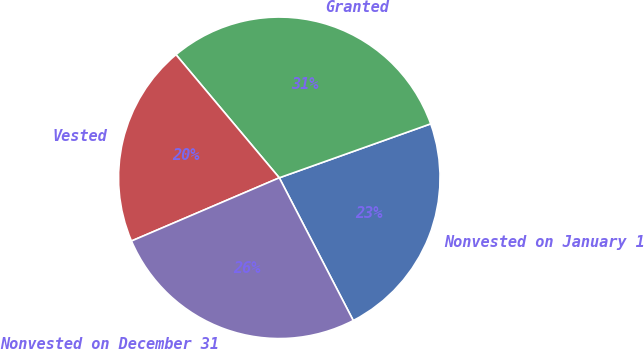Convert chart to OTSL. <chart><loc_0><loc_0><loc_500><loc_500><pie_chart><fcel>Nonvested on January 1<fcel>Granted<fcel>Vested<fcel>Nonvested on December 31<nl><fcel>22.84%<fcel>30.66%<fcel>20.32%<fcel>26.18%<nl></chart> 